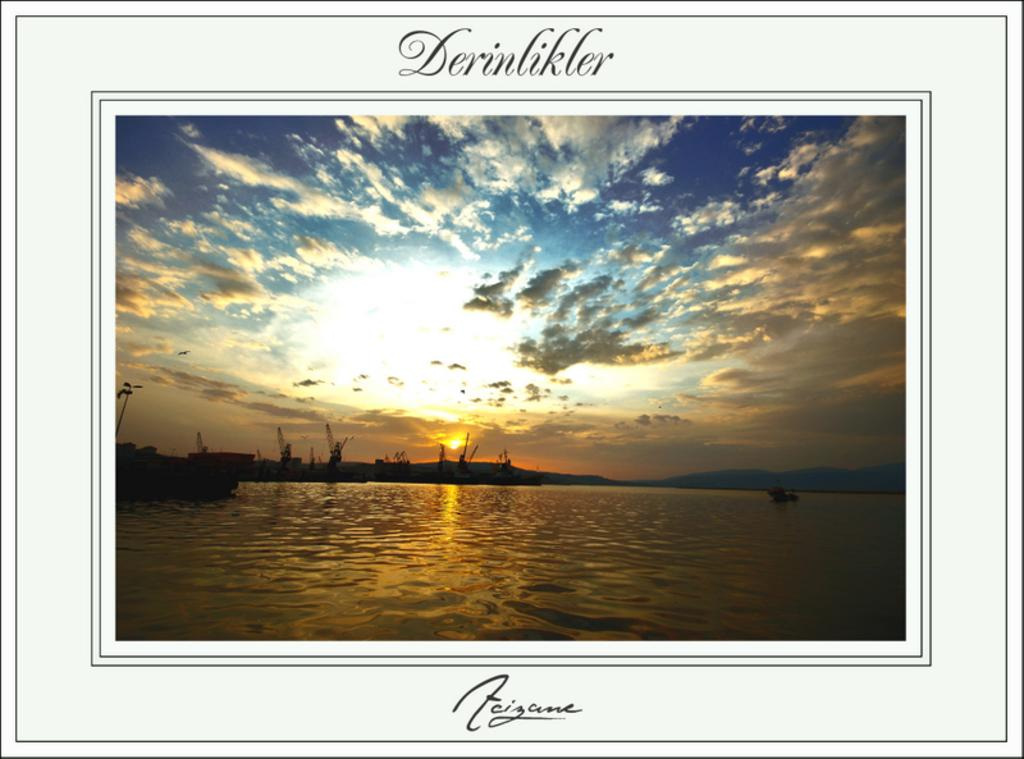What is the main object in the image? There is a frame in the image. What is inside the frame? There is water within the frame. What can be seen floating on the water? There are boats in the water. What is visible in the sky? There are clouds and the sun visible in the sky. What type of gun is being fired in the image? There is no gun or any indication of gunfire present in the image. 